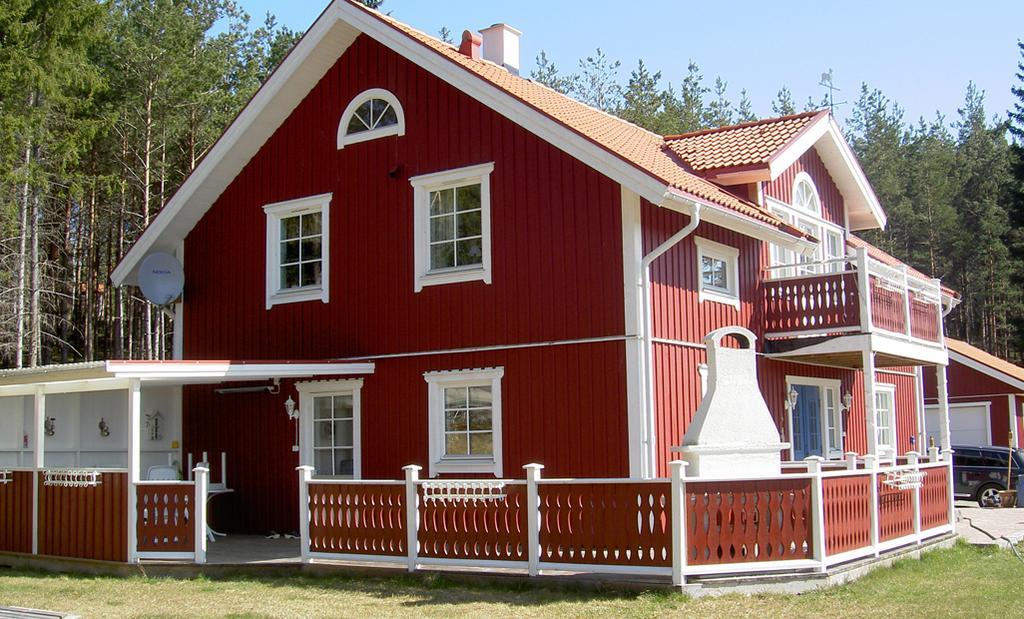Describe this image in one or two sentences. In the center of the image we can see houses, windows, roof, balcony, railing, tables, chair. On the right side of the image we can see a carport. In the background of the image we can see the trees. At the top of the image we can see the sky. At the bottom of the image we can see the ground. 